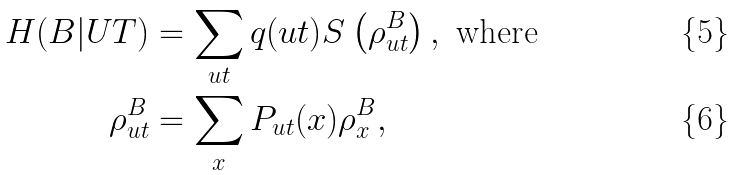<formula> <loc_0><loc_0><loc_500><loc_500>H ( B | U T ) & = \sum _ { u t } q ( u t ) S \left ( \rho ^ { B } _ { u t } \right ) , \text { where} \\ \rho ^ { B } _ { u t } & = \sum _ { x } P _ { u t } ( x ) \rho ^ { B } _ { x } ,</formula> 